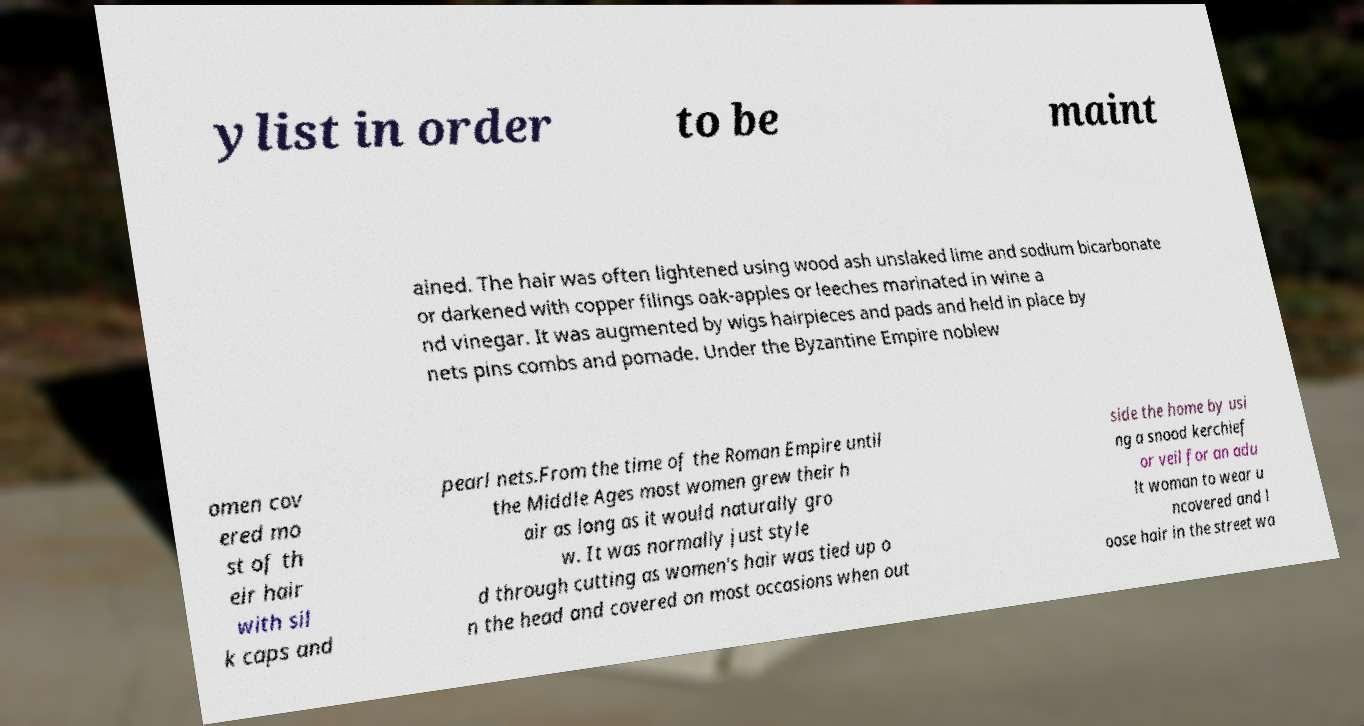What messages or text are displayed in this image? I need them in a readable, typed format. ylist in order to be maint ained. The hair was often lightened using wood ash unslaked lime and sodium bicarbonate or darkened with copper filings oak-apples or leeches marinated in wine a nd vinegar. It was augmented by wigs hairpieces and pads and held in place by nets pins combs and pomade. Under the Byzantine Empire noblew omen cov ered mo st of th eir hair with sil k caps and pearl nets.From the time of the Roman Empire until the Middle Ages most women grew their h air as long as it would naturally gro w. It was normally just style d through cutting as women's hair was tied up o n the head and covered on most occasions when out side the home by usi ng a snood kerchief or veil for an adu lt woman to wear u ncovered and l oose hair in the street wa 